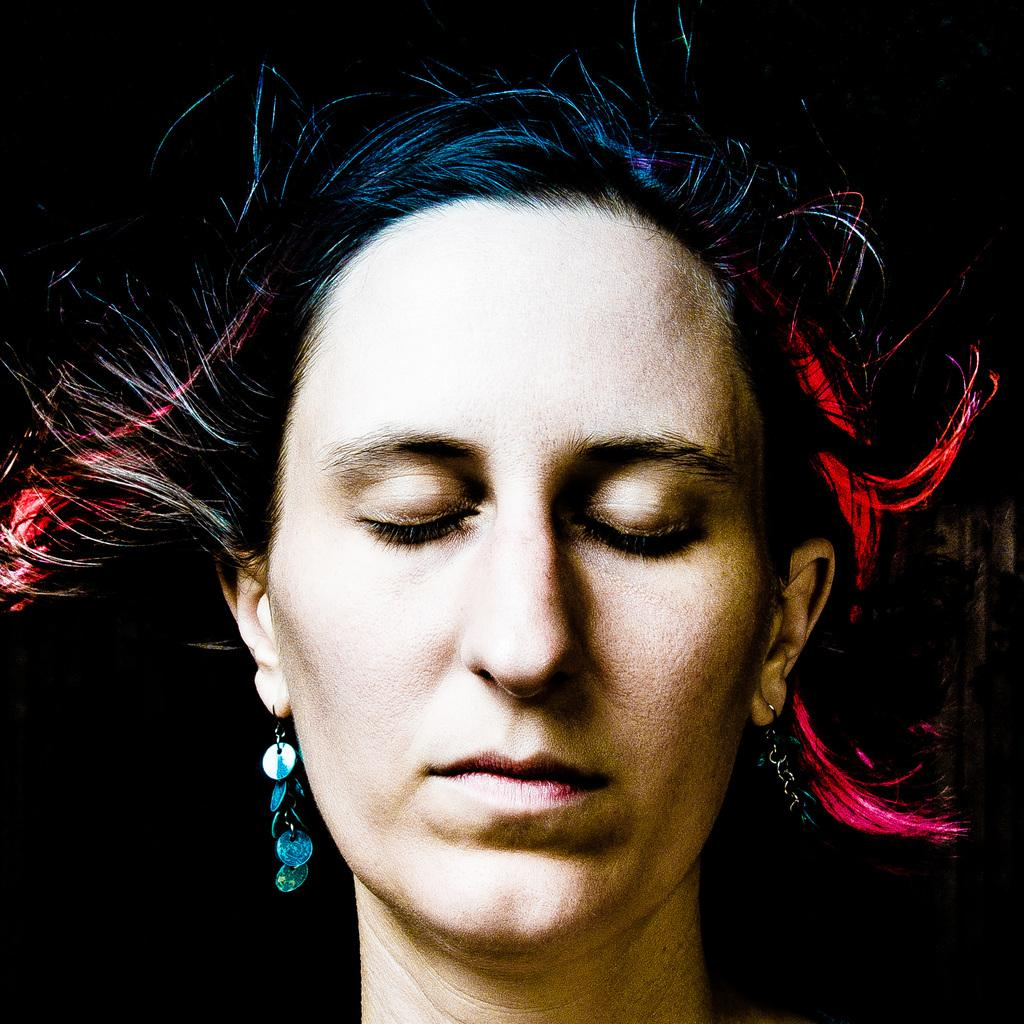Who is the main subject in the image? There is a woman in the image. What can be observed about the background of the image? The background of the image is dark. Is the woman swimming in the image? There is no indication in the image that the woman is swimming, as there is no water or swimming-related context provided. 